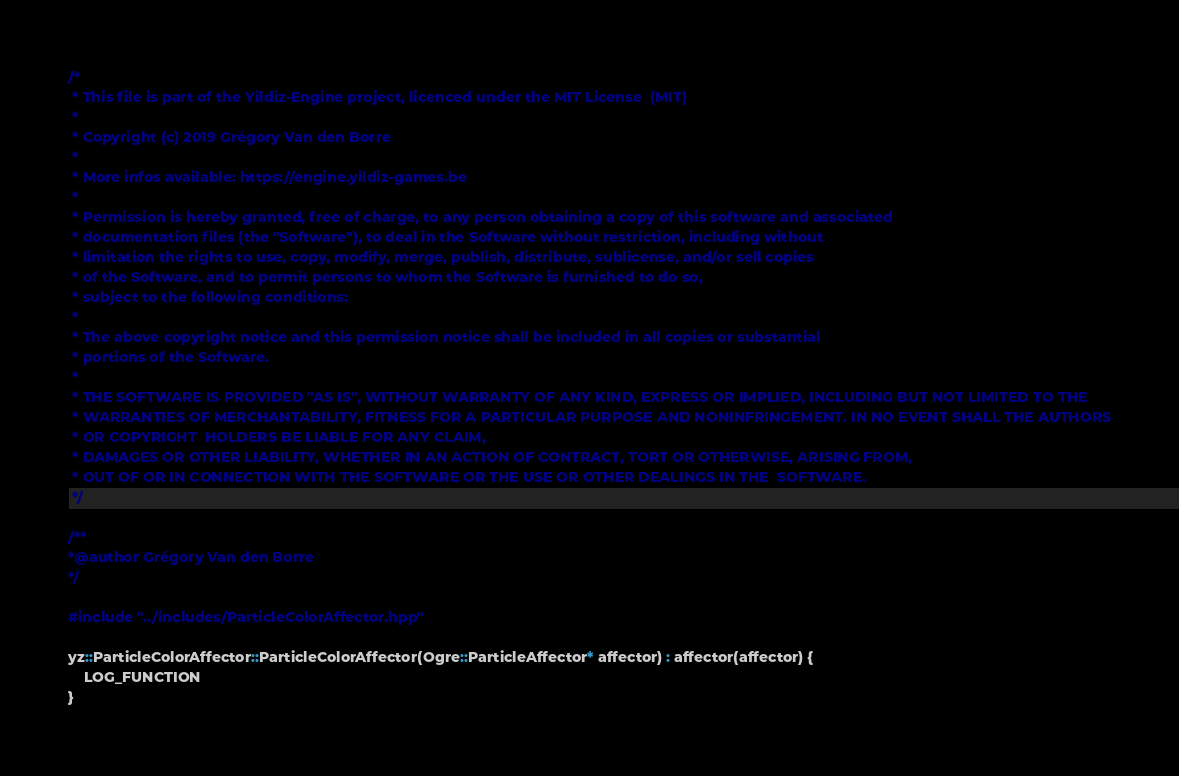Convert code to text. <code><loc_0><loc_0><loc_500><loc_500><_C++_>/*
 * This file is part of the Yildiz-Engine project, licenced under the MIT License  (MIT)
 *
 * Copyright (c) 2019 Grégory Van den Borre
 *
 * More infos available: https://engine.yildiz-games.be
 *
 * Permission is hereby granted, free of charge, to any person obtaining a copy of this software and associated
 * documentation files (the "Software"), to deal in the Software without restriction, including without
 * limitation the rights to use, copy, modify, merge, publish, distribute, sublicense, and/or sell copies
 * of the Software, and to permit persons to whom the Software is furnished to do so,
 * subject to the following conditions:
 *
 * The above copyright notice and this permission notice shall be included in all copies or substantial
 * portions of the Software.
 *
 * THE SOFTWARE IS PROVIDED "AS IS", WITHOUT WARRANTY OF ANY KIND, EXPRESS OR IMPLIED, INCLUDING BUT NOT LIMITED TO THE
 * WARRANTIES OF MERCHANTABILITY, FITNESS FOR A PARTICULAR PURPOSE AND NONINFRINGEMENT. IN NO EVENT SHALL THE AUTHORS
 * OR COPYRIGHT  HOLDERS BE LIABLE FOR ANY CLAIM,
 * DAMAGES OR OTHER LIABILITY, WHETHER IN AN ACTION OF CONTRACT, TORT OR OTHERWISE, ARISING FROM,
 * OUT OF OR IN CONNECTION WITH THE SOFTWARE OR THE USE OR OTHER DEALINGS IN THE  SOFTWARE.
 */

/**
*@author Grégory Van den Borre
*/

#include "../includes/ParticleColorAffector.hpp"

yz::ParticleColorAffector::ParticleColorAffector(Ogre::ParticleAffector* affector) : affector(affector) {
    LOG_FUNCTION
}
</code> 